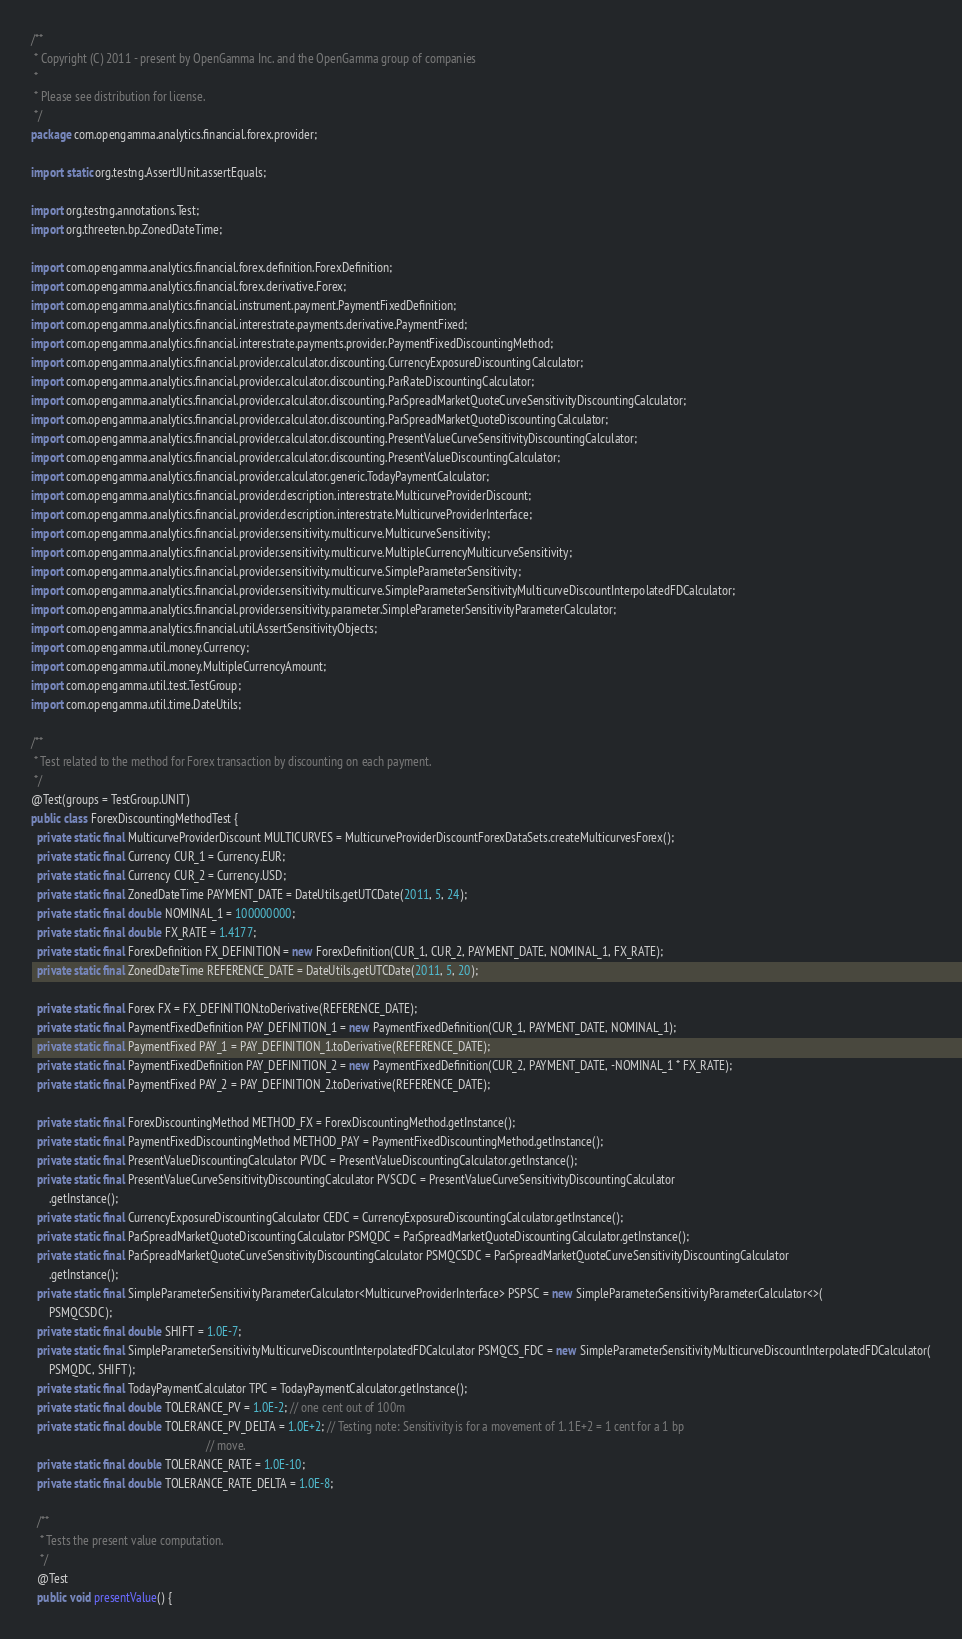Convert code to text. <code><loc_0><loc_0><loc_500><loc_500><_Java_>/**
 * Copyright (C) 2011 - present by OpenGamma Inc. and the OpenGamma group of companies
 *
 * Please see distribution for license.
 */
package com.opengamma.analytics.financial.forex.provider;

import static org.testng.AssertJUnit.assertEquals;

import org.testng.annotations.Test;
import org.threeten.bp.ZonedDateTime;

import com.opengamma.analytics.financial.forex.definition.ForexDefinition;
import com.opengamma.analytics.financial.forex.derivative.Forex;
import com.opengamma.analytics.financial.instrument.payment.PaymentFixedDefinition;
import com.opengamma.analytics.financial.interestrate.payments.derivative.PaymentFixed;
import com.opengamma.analytics.financial.interestrate.payments.provider.PaymentFixedDiscountingMethod;
import com.opengamma.analytics.financial.provider.calculator.discounting.CurrencyExposureDiscountingCalculator;
import com.opengamma.analytics.financial.provider.calculator.discounting.ParRateDiscountingCalculator;
import com.opengamma.analytics.financial.provider.calculator.discounting.ParSpreadMarketQuoteCurveSensitivityDiscountingCalculator;
import com.opengamma.analytics.financial.provider.calculator.discounting.ParSpreadMarketQuoteDiscountingCalculator;
import com.opengamma.analytics.financial.provider.calculator.discounting.PresentValueCurveSensitivityDiscountingCalculator;
import com.opengamma.analytics.financial.provider.calculator.discounting.PresentValueDiscountingCalculator;
import com.opengamma.analytics.financial.provider.calculator.generic.TodayPaymentCalculator;
import com.opengamma.analytics.financial.provider.description.interestrate.MulticurveProviderDiscount;
import com.opengamma.analytics.financial.provider.description.interestrate.MulticurveProviderInterface;
import com.opengamma.analytics.financial.provider.sensitivity.multicurve.MulticurveSensitivity;
import com.opengamma.analytics.financial.provider.sensitivity.multicurve.MultipleCurrencyMulticurveSensitivity;
import com.opengamma.analytics.financial.provider.sensitivity.multicurve.SimpleParameterSensitivity;
import com.opengamma.analytics.financial.provider.sensitivity.multicurve.SimpleParameterSensitivityMulticurveDiscountInterpolatedFDCalculator;
import com.opengamma.analytics.financial.provider.sensitivity.parameter.SimpleParameterSensitivityParameterCalculator;
import com.opengamma.analytics.financial.util.AssertSensitivityObjects;
import com.opengamma.util.money.Currency;
import com.opengamma.util.money.MultipleCurrencyAmount;
import com.opengamma.util.test.TestGroup;
import com.opengamma.util.time.DateUtils;

/**
 * Test related to the method for Forex transaction by discounting on each payment.
 */
@Test(groups = TestGroup.UNIT)
public class ForexDiscountingMethodTest {
  private static final MulticurveProviderDiscount MULTICURVES = MulticurveProviderDiscountForexDataSets.createMulticurvesForex();
  private static final Currency CUR_1 = Currency.EUR;
  private static final Currency CUR_2 = Currency.USD;
  private static final ZonedDateTime PAYMENT_DATE = DateUtils.getUTCDate(2011, 5, 24);
  private static final double NOMINAL_1 = 100000000;
  private static final double FX_RATE = 1.4177;
  private static final ForexDefinition FX_DEFINITION = new ForexDefinition(CUR_1, CUR_2, PAYMENT_DATE, NOMINAL_1, FX_RATE);
  private static final ZonedDateTime REFERENCE_DATE = DateUtils.getUTCDate(2011, 5, 20);

  private static final Forex FX = FX_DEFINITION.toDerivative(REFERENCE_DATE);
  private static final PaymentFixedDefinition PAY_DEFINITION_1 = new PaymentFixedDefinition(CUR_1, PAYMENT_DATE, NOMINAL_1);
  private static final PaymentFixed PAY_1 = PAY_DEFINITION_1.toDerivative(REFERENCE_DATE);
  private static final PaymentFixedDefinition PAY_DEFINITION_2 = new PaymentFixedDefinition(CUR_2, PAYMENT_DATE, -NOMINAL_1 * FX_RATE);
  private static final PaymentFixed PAY_2 = PAY_DEFINITION_2.toDerivative(REFERENCE_DATE);

  private static final ForexDiscountingMethod METHOD_FX = ForexDiscountingMethod.getInstance();
  private static final PaymentFixedDiscountingMethod METHOD_PAY = PaymentFixedDiscountingMethod.getInstance();
  private static final PresentValueDiscountingCalculator PVDC = PresentValueDiscountingCalculator.getInstance();
  private static final PresentValueCurveSensitivityDiscountingCalculator PVSCDC = PresentValueCurveSensitivityDiscountingCalculator
      .getInstance();
  private static final CurrencyExposureDiscountingCalculator CEDC = CurrencyExposureDiscountingCalculator.getInstance();
  private static final ParSpreadMarketQuoteDiscountingCalculator PSMQDC = ParSpreadMarketQuoteDiscountingCalculator.getInstance();
  private static final ParSpreadMarketQuoteCurveSensitivityDiscountingCalculator PSMQCSDC = ParSpreadMarketQuoteCurveSensitivityDiscountingCalculator
      .getInstance();
  private static final SimpleParameterSensitivityParameterCalculator<MulticurveProviderInterface> PSPSC = new SimpleParameterSensitivityParameterCalculator<>(
      PSMQCSDC);
  private static final double SHIFT = 1.0E-7;
  private static final SimpleParameterSensitivityMulticurveDiscountInterpolatedFDCalculator PSMQCS_FDC = new SimpleParameterSensitivityMulticurveDiscountInterpolatedFDCalculator(
      PSMQDC, SHIFT);
  private static final TodayPaymentCalculator TPC = TodayPaymentCalculator.getInstance();
  private static final double TOLERANCE_PV = 1.0E-2; // one cent out of 100m
  private static final double TOLERANCE_PV_DELTA = 1.0E+2; // Testing note: Sensitivity is for a movement of 1. 1E+2 = 1 cent for a 1 bp
                                                           // move.
  private static final double TOLERANCE_RATE = 1.0E-10;
  private static final double TOLERANCE_RATE_DELTA = 1.0E-8;

  /**
   * Tests the present value computation.
   */
  @Test
  public void presentValue() {</code> 